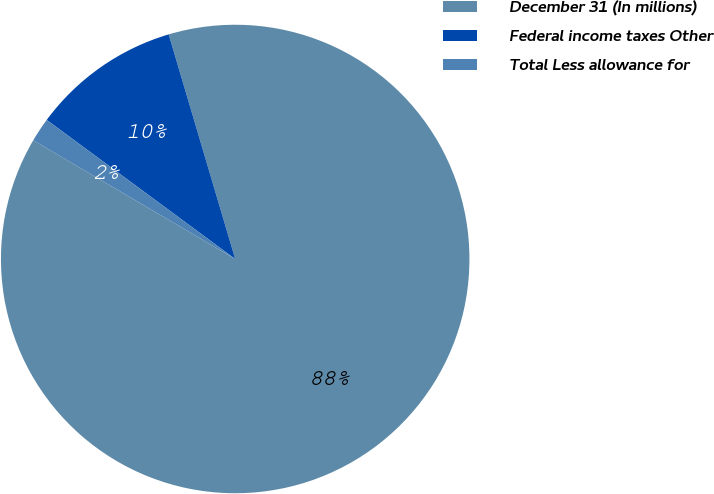Convert chart to OTSL. <chart><loc_0><loc_0><loc_500><loc_500><pie_chart><fcel>December 31 (In millions)<fcel>Federal income taxes Other<fcel>Total Less allowance for<nl><fcel>88.04%<fcel>10.3%<fcel>1.66%<nl></chart> 